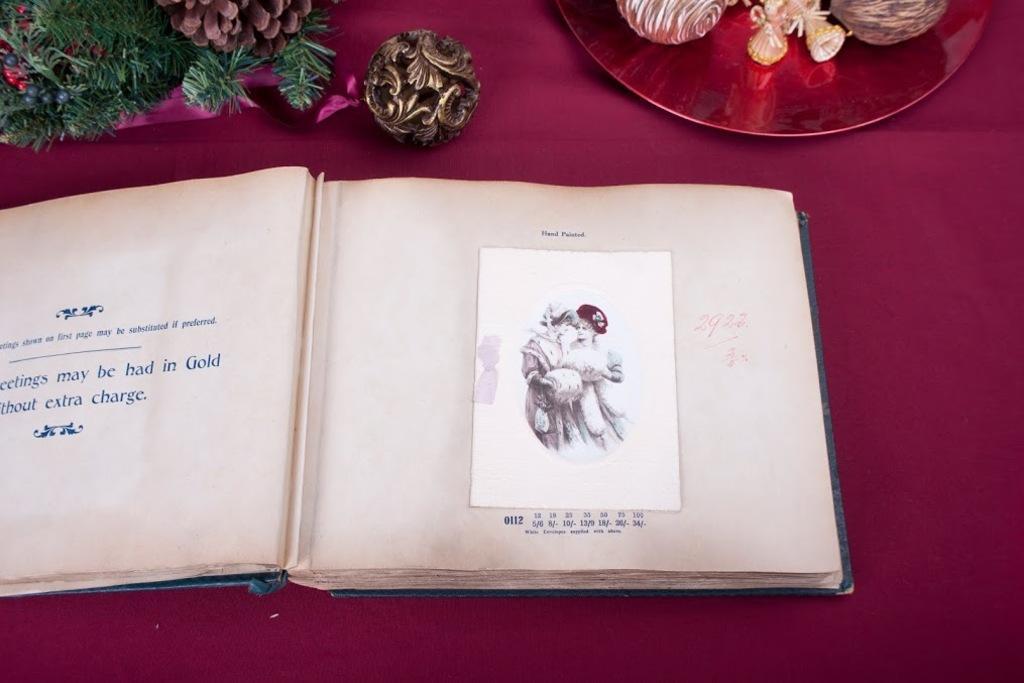Please provide a concise description of this image. In this picture there is a book and there are objects on the table and there are pictures of a two people and there is text on the book and there is a maroon color cloth on the table. 